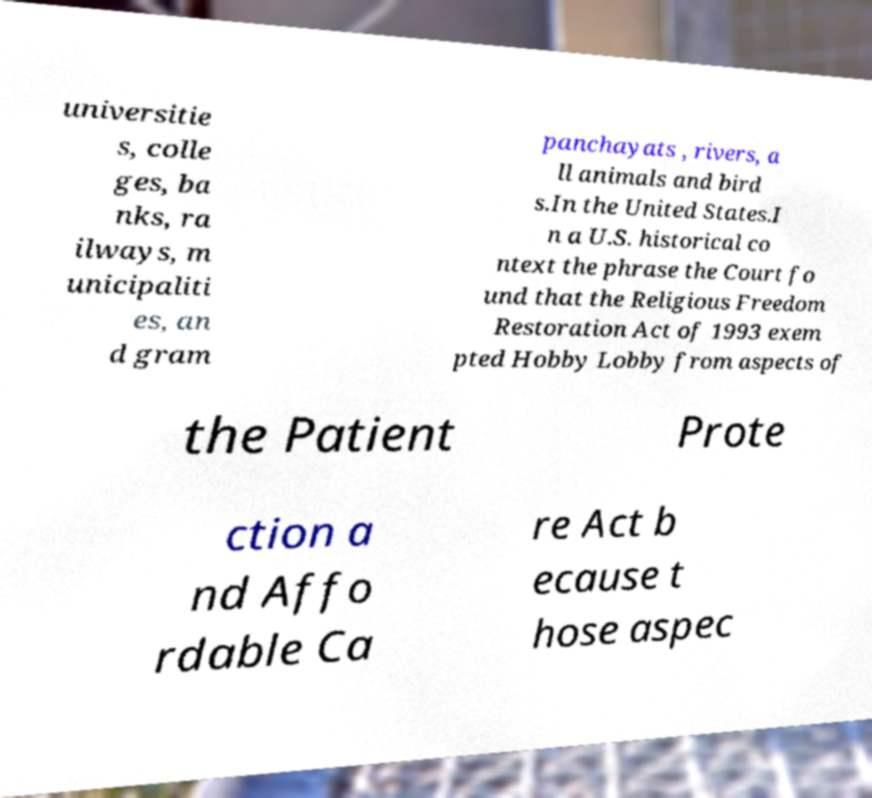For documentation purposes, I need the text within this image transcribed. Could you provide that? universitie s, colle ges, ba nks, ra ilways, m unicipaliti es, an d gram panchayats , rivers, a ll animals and bird s.In the United States.I n a U.S. historical co ntext the phrase the Court fo und that the Religious Freedom Restoration Act of 1993 exem pted Hobby Lobby from aspects of the Patient Prote ction a nd Affo rdable Ca re Act b ecause t hose aspec 